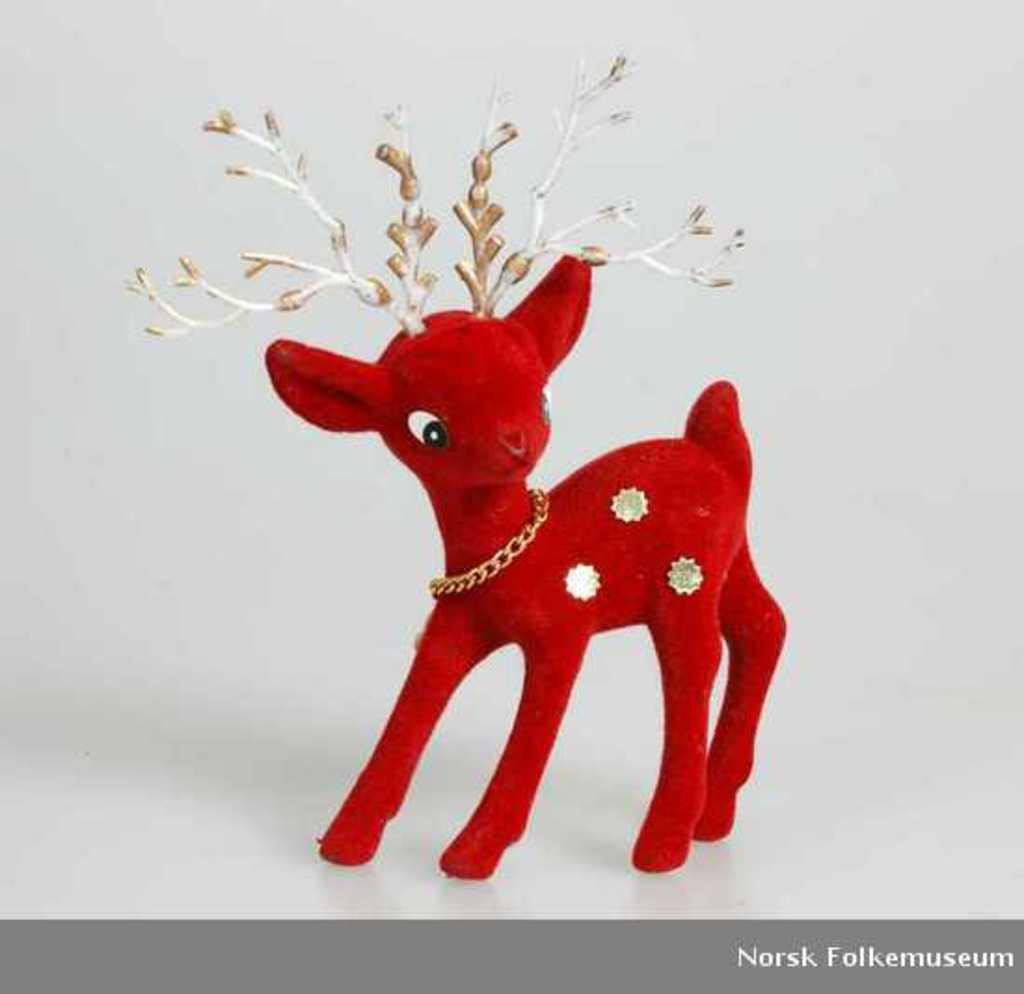What type of toy is present in the image? The image features a toy deer. What color is the toy deer? The toy deer is red in color. What can be seen in the background of the image? The background of the image appears white. Is there any text or marking at the bottom of the image? Yes, there is a watermark at the bottom of the image. How does the toy deer fall from the tree in the image? There is no tree or falling action depicted in the image; it only features a stationary toy deer. What type of reward does the toy deer receive for completing the task in the image? There is no task or reward mentioned or depicted in the image; it only features a stationary toy deer. 